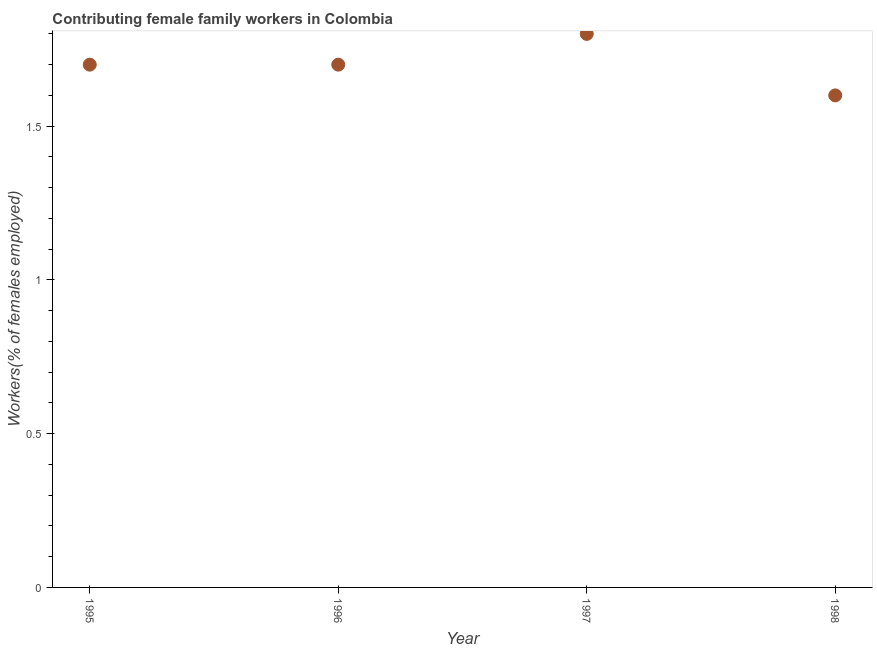What is the contributing female family workers in 1995?
Offer a very short reply. 1.7. Across all years, what is the maximum contributing female family workers?
Offer a very short reply. 1.8. Across all years, what is the minimum contributing female family workers?
Offer a terse response. 1.6. In which year was the contributing female family workers maximum?
Offer a very short reply. 1997. In which year was the contributing female family workers minimum?
Make the answer very short. 1998. What is the sum of the contributing female family workers?
Make the answer very short. 6.8. What is the difference between the contributing female family workers in 1995 and 1997?
Ensure brevity in your answer.  -0.1. What is the average contributing female family workers per year?
Offer a terse response. 1.7. What is the median contributing female family workers?
Make the answer very short. 1.7. In how many years, is the contributing female family workers greater than 1.6 %?
Offer a very short reply. 4. What is the ratio of the contributing female family workers in 1997 to that in 1998?
Provide a succinct answer. 1.12. What is the difference between the highest and the second highest contributing female family workers?
Your answer should be very brief. 0.1. What is the difference between the highest and the lowest contributing female family workers?
Your answer should be compact. 0.2. In how many years, is the contributing female family workers greater than the average contributing female family workers taken over all years?
Provide a short and direct response. 3. Does the contributing female family workers monotonically increase over the years?
Ensure brevity in your answer.  No. How many dotlines are there?
Provide a short and direct response. 1. What is the title of the graph?
Provide a short and direct response. Contributing female family workers in Colombia. What is the label or title of the Y-axis?
Your answer should be very brief. Workers(% of females employed). What is the Workers(% of females employed) in 1995?
Keep it short and to the point. 1.7. What is the Workers(% of females employed) in 1996?
Your response must be concise. 1.7. What is the Workers(% of females employed) in 1997?
Make the answer very short. 1.8. What is the Workers(% of females employed) in 1998?
Offer a terse response. 1.6. What is the difference between the Workers(% of females employed) in 1995 and 1996?
Ensure brevity in your answer.  0. What is the difference between the Workers(% of females employed) in 1995 and 1997?
Your answer should be very brief. -0.1. What is the difference between the Workers(% of females employed) in 1995 and 1998?
Make the answer very short. 0.1. What is the difference between the Workers(% of females employed) in 1996 and 1997?
Give a very brief answer. -0.1. What is the difference between the Workers(% of females employed) in 1997 and 1998?
Offer a very short reply. 0.2. What is the ratio of the Workers(% of females employed) in 1995 to that in 1997?
Your answer should be very brief. 0.94. What is the ratio of the Workers(% of females employed) in 1995 to that in 1998?
Make the answer very short. 1.06. What is the ratio of the Workers(% of females employed) in 1996 to that in 1997?
Ensure brevity in your answer.  0.94. What is the ratio of the Workers(% of females employed) in 1996 to that in 1998?
Provide a short and direct response. 1.06. 